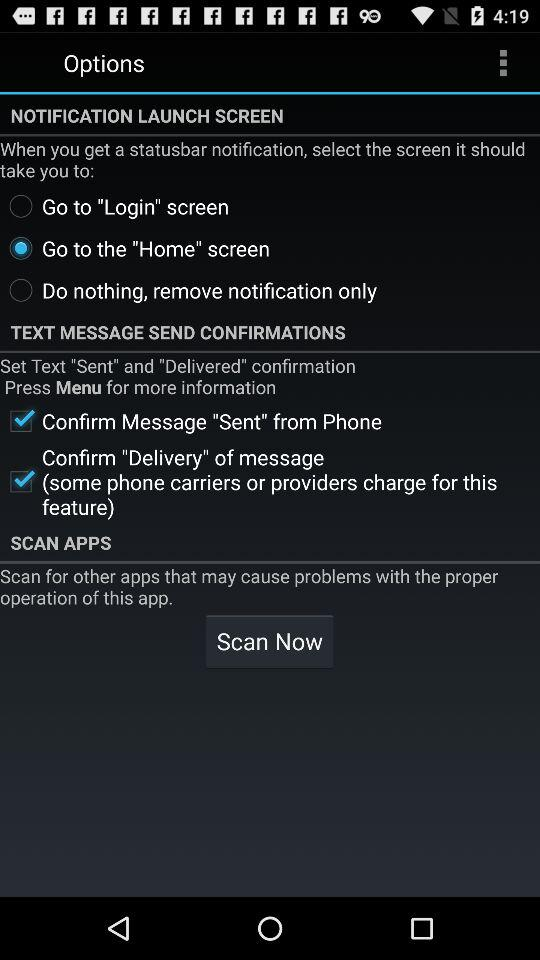Which setting is selected for "NOTIFICATION LAUNCH SCREEN"? The selected setting is "Go to the "Home" screen". 